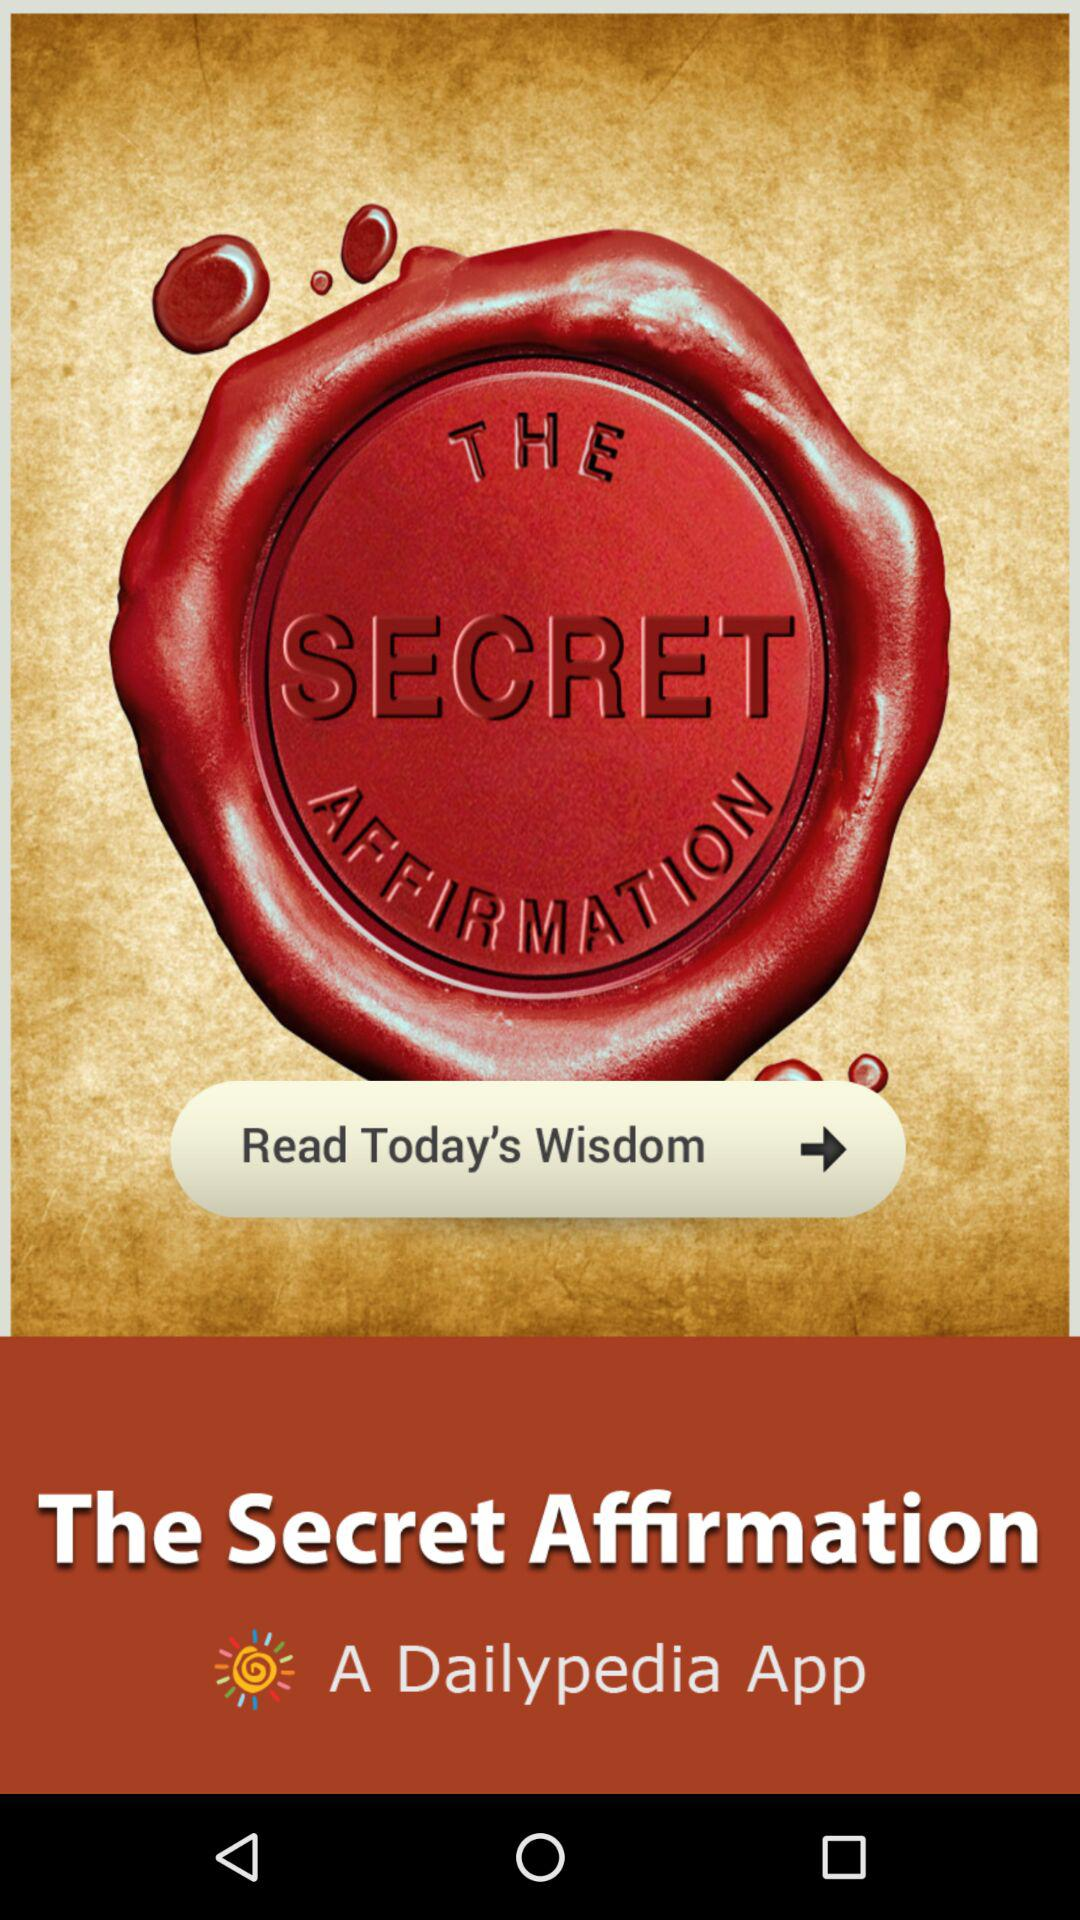What is the name of the application? The name of the application is "The Secret Affirmation". 